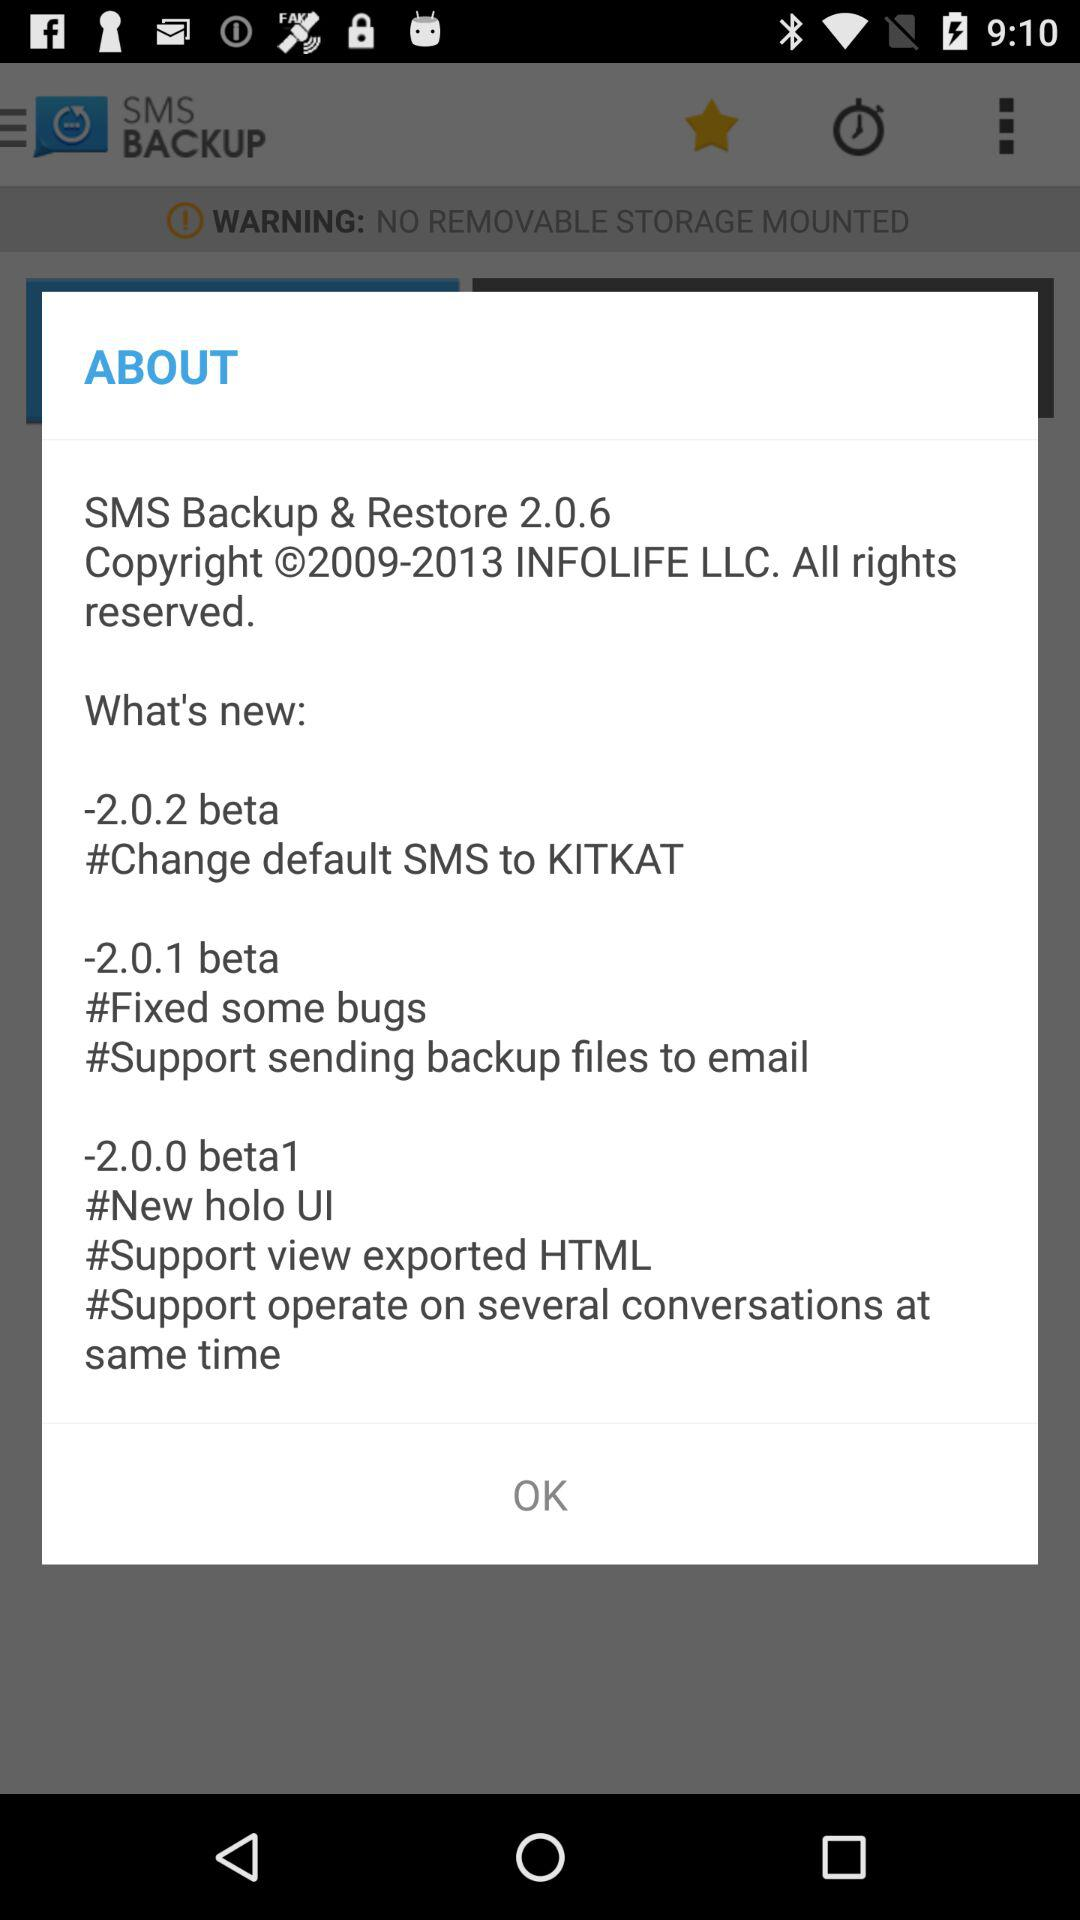What is the new update in version 2.0.0 beta1? The new updates in version 2.0.0 beta1 are "New holo UI", "Support view exported HTML" and "Support operate on several conversations at same time". 